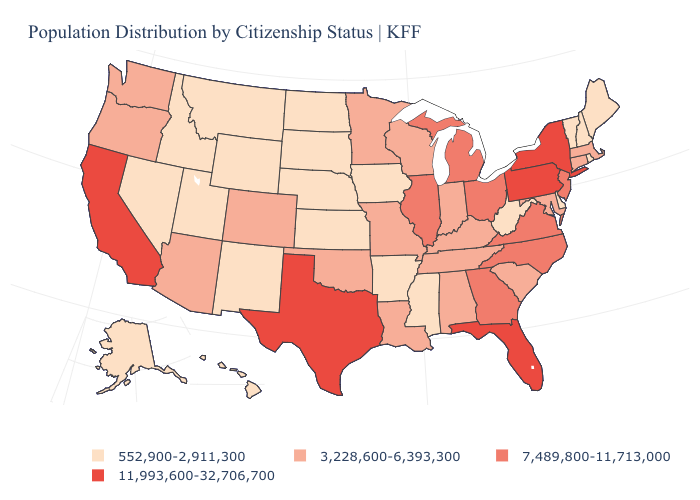Among the states that border West Virginia , which have the highest value?
Give a very brief answer. Pennsylvania. Does the map have missing data?
Write a very short answer. No. Among the states that border Utah , which have the lowest value?
Answer briefly. Idaho, Nevada, New Mexico, Wyoming. Among the states that border Oregon , does Washington have the lowest value?
Write a very short answer. No. Among the states that border Tennessee , does Arkansas have the lowest value?
Concise answer only. Yes. Among the states that border Louisiana , does Texas have the highest value?
Concise answer only. Yes. Does Washington have the same value as Indiana?
Keep it brief. Yes. Among the states that border North Dakota , does South Dakota have the highest value?
Be succinct. No. What is the value of New York?
Answer briefly. 11,993,600-32,706,700. What is the value of Vermont?
Give a very brief answer. 552,900-2,911,300. Name the states that have a value in the range 552,900-2,911,300?
Short answer required. Alaska, Arkansas, Delaware, Hawaii, Idaho, Iowa, Kansas, Maine, Mississippi, Montana, Nebraska, Nevada, New Hampshire, New Mexico, North Dakota, Rhode Island, South Dakota, Utah, Vermont, West Virginia, Wyoming. What is the value of Alabama?
Quick response, please. 3,228,600-6,393,300. Does Wyoming have the same value as Pennsylvania?
Quick response, please. No. Among the states that border Kansas , does Nebraska have the lowest value?
Give a very brief answer. Yes. What is the value of Illinois?
Be succinct. 7,489,800-11,713,000. 